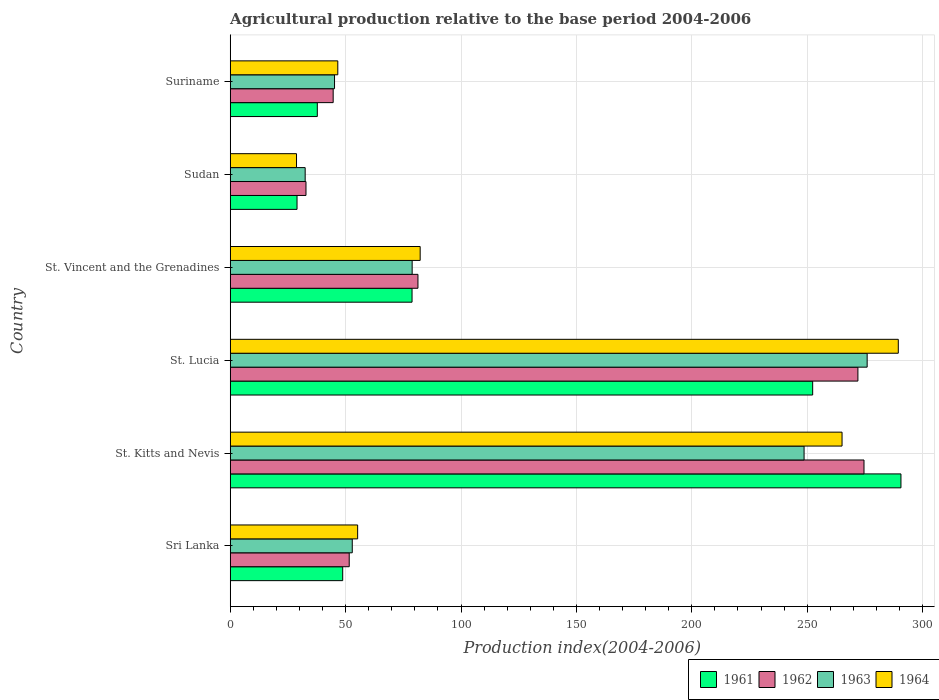Are the number of bars per tick equal to the number of legend labels?
Provide a short and direct response. Yes. Are the number of bars on each tick of the Y-axis equal?
Provide a short and direct response. Yes. How many bars are there on the 2nd tick from the bottom?
Your response must be concise. 4. What is the label of the 2nd group of bars from the top?
Your response must be concise. Sudan. In how many cases, is the number of bars for a given country not equal to the number of legend labels?
Provide a short and direct response. 0. What is the agricultural production index in 1961 in St. Lucia?
Your answer should be very brief. 252.36. Across all countries, what is the maximum agricultural production index in 1962?
Offer a terse response. 274.6. Across all countries, what is the minimum agricultural production index in 1961?
Your response must be concise. 28.96. In which country was the agricultural production index in 1961 maximum?
Make the answer very short. St. Kitts and Nevis. In which country was the agricultural production index in 1961 minimum?
Your response must be concise. Sudan. What is the total agricultural production index in 1963 in the graph?
Your response must be concise. 734.04. What is the difference between the agricultural production index in 1963 in St. Lucia and the agricultural production index in 1961 in Sri Lanka?
Give a very brief answer. 227.22. What is the average agricultural production index in 1961 per country?
Keep it short and to the point. 122.87. What is the difference between the agricultural production index in 1961 and agricultural production index in 1963 in Suriname?
Offer a very short reply. -7.46. What is the ratio of the agricultural production index in 1963 in St. Lucia to that in Sudan?
Provide a succinct answer. 8.49. Is the agricultural production index in 1964 in St. Vincent and the Grenadines less than that in Suriname?
Give a very brief answer. No. Is the difference between the agricultural production index in 1961 in St. Lucia and Suriname greater than the difference between the agricultural production index in 1963 in St. Lucia and Suriname?
Provide a short and direct response. No. What is the difference between the highest and the second highest agricultural production index in 1962?
Your response must be concise. 2.64. What is the difference between the highest and the lowest agricultural production index in 1963?
Offer a terse response. 243.48. In how many countries, is the agricultural production index in 1961 greater than the average agricultural production index in 1961 taken over all countries?
Your answer should be compact. 2. Is it the case that in every country, the sum of the agricultural production index in 1963 and agricultural production index in 1964 is greater than the sum of agricultural production index in 1961 and agricultural production index in 1962?
Make the answer very short. No. What does the 1st bar from the top in St. Vincent and the Grenadines represents?
Your answer should be very brief. 1964. What does the 2nd bar from the bottom in St. Vincent and the Grenadines represents?
Make the answer very short. 1962. How many bars are there?
Provide a short and direct response. 24. Are all the bars in the graph horizontal?
Give a very brief answer. Yes. What is the difference between two consecutive major ticks on the X-axis?
Keep it short and to the point. 50. Does the graph contain any zero values?
Offer a very short reply. No. Does the graph contain grids?
Your answer should be compact. Yes. How many legend labels are there?
Offer a very short reply. 4. What is the title of the graph?
Your answer should be compact. Agricultural production relative to the base period 2004-2006. Does "1982" appear as one of the legend labels in the graph?
Keep it short and to the point. No. What is the label or title of the X-axis?
Ensure brevity in your answer.  Production index(2004-2006). What is the Production index(2004-2006) of 1961 in Sri Lanka?
Your answer should be very brief. 48.75. What is the Production index(2004-2006) of 1962 in Sri Lanka?
Offer a very short reply. 51.57. What is the Production index(2004-2006) in 1963 in Sri Lanka?
Keep it short and to the point. 52.89. What is the Production index(2004-2006) in 1964 in Sri Lanka?
Offer a terse response. 55.22. What is the Production index(2004-2006) of 1961 in St. Kitts and Nevis?
Offer a very short reply. 290.61. What is the Production index(2004-2006) of 1962 in St. Kitts and Nevis?
Keep it short and to the point. 274.6. What is the Production index(2004-2006) of 1963 in St. Kitts and Nevis?
Offer a very short reply. 248.64. What is the Production index(2004-2006) of 1964 in St. Kitts and Nevis?
Your answer should be very brief. 265.09. What is the Production index(2004-2006) in 1961 in St. Lucia?
Offer a very short reply. 252.36. What is the Production index(2004-2006) of 1962 in St. Lucia?
Keep it short and to the point. 271.96. What is the Production index(2004-2006) in 1963 in St. Lucia?
Your response must be concise. 275.97. What is the Production index(2004-2006) of 1964 in St. Lucia?
Provide a short and direct response. 289.46. What is the Production index(2004-2006) in 1961 in St. Vincent and the Grenadines?
Your answer should be very brief. 78.79. What is the Production index(2004-2006) in 1962 in St. Vincent and the Grenadines?
Provide a succinct answer. 81.35. What is the Production index(2004-2006) in 1963 in St. Vincent and the Grenadines?
Offer a very short reply. 78.84. What is the Production index(2004-2006) of 1964 in St. Vincent and the Grenadines?
Provide a succinct answer. 82.31. What is the Production index(2004-2006) in 1961 in Sudan?
Offer a terse response. 28.96. What is the Production index(2004-2006) of 1962 in Sudan?
Your answer should be compact. 32.84. What is the Production index(2004-2006) of 1963 in Sudan?
Your answer should be compact. 32.49. What is the Production index(2004-2006) in 1964 in Sudan?
Make the answer very short. 28.74. What is the Production index(2004-2006) in 1961 in Suriname?
Provide a succinct answer. 37.75. What is the Production index(2004-2006) of 1962 in Suriname?
Offer a terse response. 44.62. What is the Production index(2004-2006) of 1963 in Suriname?
Your response must be concise. 45.21. What is the Production index(2004-2006) in 1964 in Suriname?
Your answer should be compact. 46.62. Across all countries, what is the maximum Production index(2004-2006) of 1961?
Your answer should be compact. 290.61. Across all countries, what is the maximum Production index(2004-2006) of 1962?
Your answer should be compact. 274.6. Across all countries, what is the maximum Production index(2004-2006) in 1963?
Your answer should be compact. 275.97. Across all countries, what is the maximum Production index(2004-2006) in 1964?
Make the answer very short. 289.46. Across all countries, what is the minimum Production index(2004-2006) of 1961?
Give a very brief answer. 28.96. Across all countries, what is the minimum Production index(2004-2006) in 1962?
Make the answer very short. 32.84. Across all countries, what is the minimum Production index(2004-2006) in 1963?
Keep it short and to the point. 32.49. Across all countries, what is the minimum Production index(2004-2006) of 1964?
Offer a very short reply. 28.74. What is the total Production index(2004-2006) of 1961 in the graph?
Provide a succinct answer. 737.22. What is the total Production index(2004-2006) in 1962 in the graph?
Offer a very short reply. 756.94. What is the total Production index(2004-2006) of 1963 in the graph?
Your answer should be compact. 734.04. What is the total Production index(2004-2006) in 1964 in the graph?
Give a very brief answer. 767.44. What is the difference between the Production index(2004-2006) of 1961 in Sri Lanka and that in St. Kitts and Nevis?
Provide a short and direct response. -241.86. What is the difference between the Production index(2004-2006) in 1962 in Sri Lanka and that in St. Kitts and Nevis?
Keep it short and to the point. -223.03. What is the difference between the Production index(2004-2006) in 1963 in Sri Lanka and that in St. Kitts and Nevis?
Keep it short and to the point. -195.75. What is the difference between the Production index(2004-2006) in 1964 in Sri Lanka and that in St. Kitts and Nevis?
Give a very brief answer. -209.87. What is the difference between the Production index(2004-2006) of 1961 in Sri Lanka and that in St. Lucia?
Offer a very short reply. -203.61. What is the difference between the Production index(2004-2006) in 1962 in Sri Lanka and that in St. Lucia?
Your answer should be compact. -220.39. What is the difference between the Production index(2004-2006) of 1963 in Sri Lanka and that in St. Lucia?
Offer a terse response. -223.08. What is the difference between the Production index(2004-2006) in 1964 in Sri Lanka and that in St. Lucia?
Provide a succinct answer. -234.24. What is the difference between the Production index(2004-2006) of 1961 in Sri Lanka and that in St. Vincent and the Grenadines?
Keep it short and to the point. -30.04. What is the difference between the Production index(2004-2006) of 1962 in Sri Lanka and that in St. Vincent and the Grenadines?
Keep it short and to the point. -29.78. What is the difference between the Production index(2004-2006) in 1963 in Sri Lanka and that in St. Vincent and the Grenadines?
Your answer should be very brief. -25.95. What is the difference between the Production index(2004-2006) in 1964 in Sri Lanka and that in St. Vincent and the Grenadines?
Offer a terse response. -27.09. What is the difference between the Production index(2004-2006) in 1961 in Sri Lanka and that in Sudan?
Keep it short and to the point. 19.79. What is the difference between the Production index(2004-2006) in 1962 in Sri Lanka and that in Sudan?
Your answer should be compact. 18.73. What is the difference between the Production index(2004-2006) of 1963 in Sri Lanka and that in Sudan?
Keep it short and to the point. 20.4. What is the difference between the Production index(2004-2006) in 1964 in Sri Lanka and that in Sudan?
Your answer should be compact. 26.48. What is the difference between the Production index(2004-2006) of 1962 in Sri Lanka and that in Suriname?
Your answer should be compact. 6.95. What is the difference between the Production index(2004-2006) of 1963 in Sri Lanka and that in Suriname?
Make the answer very short. 7.68. What is the difference between the Production index(2004-2006) in 1961 in St. Kitts and Nevis and that in St. Lucia?
Your answer should be compact. 38.25. What is the difference between the Production index(2004-2006) of 1962 in St. Kitts and Nevis and that in St. Lucia?
Give a very brief answer. 2.64. What is the difference between the Production index(2004-2006) in 1963 in St. Kitts and Nevis and that in St. Lucia?
Offer a terse response. -27.33. What is the difference between the Production index(2004-2006) of 1964 in St. Kitts and Nevis and that in St. Lucia?
Provide a short and direct response. -24.37. What is the difference between the Production index(2004-2006) of 1961 in St. Kitts and Nevis and that in St. Vincent and the Grenadines?
Give a very brief answer. 211.82. What is the difference between the Production index(2004-2006) in 1962 in St. Kitts and Nevis and that in St. Vincent and the Grenadines?
Make the answer very short. 193.25. What is the difference between the Production index(2004-2006) in 1963 in St. Kitts and Nevis and that in St. Vincent and the Grenadines?
Provide a succinct answer. 169.8. What is the difference between the Production index(2004-2006) of 1964 in St. Kitts and Nevis and that in St. Vincent and the Grenadines?
Keep it short and to the point. 182.78. What is the difference between the Production index(2004-2006) in 1961 in St. Kitts and Nevis and that in Sudan?
Keep it short and to the point. 261.65. What is the difference between the Production index(2004-2006) in 1962 in St. Kitts and Nevis and that in Sudan?
Your answer should be very brief. 241.76. What is the difference between the Production index(2004-2006) in 1963 in St. Kitts and Nevis and that in Sudan?
Offer a very short reply. 216.15. What is the difference between the Production index(2004-2006) of 1964 in St. Kitts and Nevis and that in Sudan?
Offer a terse response. 236.35. What is the difference between the Production index(2004-2006) in 1961 in St. Kitts and Nevis and that in Suriname?
Keep it short and to the point. 252.86. What is the difference between the Production index(2004-2006) in 1962 in St. Kitts and Nevis and that in Suriname?
Offer a very short reply. 229.98. What is the difference between the Production index(2004-2006) in 1963 in St. Kitts and Nevis and that in Suriname?
Ensure brevity in your answer.  203.43. What is the difference between the Production index(2004-2006) in 1964 in St. Kitts and Nevis and that in Suriname?
Offer a very short reply. 218.47. What is the difference between the Production index(2004-2006) in 1961 in St. Lucia and that in St. Vincent and the Grenadines?
Ensure brevity in your answer.  173.57. What is the difference between the Production index(2004-2006) of 1962 in St. Lucia and that in St. Vincent and the Grenadines?
Offer a very short reply. 190.61. What is the difference between the Production index(2004-2006) of 1963 in St. Lucia and that in St. Vincent and the Grenadines?
Make the answer very short. 197.13. What is the difference between the Production index(2004-2006) in 1964 in St. Lucia and that in St. Vincent and the Grenadines?
Keep it short and to the point. 207.15. What is the difference between the Production index(2004-2006) of 1961 in St. Lucia and that in Sudan?
Keep it short and to the point. 223.4. What is the difference between the Production index(2004-2006) in 1962 in St. Lucia and that in Sudan?
Ensure brevity in your answer.  239.12. What is the difference between the Production index(2004-2006) in 1963 in St. Lucia and that in Sudan?
Your answer should be compact. 243.48. What is the difference between the Production index(2004-2006) of 1964 in St. Lucia and that in Sudan?
Ensure brevity in your answer.  260.72. What is the difference between the Production index(2004-2006) of 1961 in St. Lucia and that in Suriname?
Keep it short and to the point. 214.61. What is the difference between the Production index(2004-2006) in 1962 in St. Lucia and that in Suriname?
Your answer should be very brief. 227.34. What is the difference between the Production index(2004-2006) of 1963 in St. Lucia and that in Suriname?
Your response must be concise. 230.76. What is the difference between the Production index(2004-2006) of 1964 in St. Lucia and that in Suriname?
Your response must be concise. 242.84. What is the difference between the Production index(2004-2006) in 1961 in St. Vincent and the Grenadines and that in Sudan?
Offer a terse response. 49.83. What is the difference between the Production index(2004-2006) in 1962 in St. Vincent and the Grenadines and that in Sudan?
Make the answer very short. 48.51. What is the difference between the Production index(2004-2006) of 1963 in St. Vincent and the Grenadines and that in Sudan?
Ensure brevity in your answer.  46.35. What is the difference between the Production index(2004-2006) in 1964 in St. Vincent and the Grenadines and that in Sudan?
Make the answer very short. 53.57. What is the difference between the Production index(2004-2006) of 1961 in St. Vincent and the Grenadines and that in Suriname?
Ensure brevity in your answer.  41.04. What is the difference between the Production index(2004-2006) in 1962 in St. Vincent and the Grenadines and that in Suriname?
Provide a short and direct response. 36.73. What is the difference between the Production index(2004-2006) of 1963 in St. Vincent and the Grenadines and that in Suriname?
Offer a very short reply. 33.63. What is the difference between the Production index(2004-2006) in 1964 in St. Vincent and the Grenadines and that in Suriname?
Your answer should be very brief. 35.69. What is the difference between the Production index(2004-2006) in 1961 in Sudan and that in Suriname?
Provide a short and direct response. -8.79. What is the difference between the Production index(2004-2006) of 1962 in Sudan and that in Suriname?
Your answer should be very brief. -11.78. What is the difference between the Production index(2004-2006) of 1963 in Sudan and that in Suriname?
Provide a succinct answer. -12.72. What is the difference between the Production index(2004-2006) of 1964 in Sudan and that in Suriname?
Your response must be concise. -17.88. What is the difference between the Production index(2004-2006) of 1961 in Sri Lanka and the Production index(2004-2006) of 1962 in St. Kitts and Nevis?
Provide a succinct answer. -225.85. What is the difference between the Production index(2004-2006) of 1961 in Sri Lanka and the Production index(2004-2006) of 1963 in St. Kitts and Nevis?
Provide a short and direct response. -199.89. What is the difference between the Production index(2004-2006) of 1961 in Sri Lanka and the Production index(2004-2006) of 1964 in St. Kitts and Nevis?
Provide a succinct answer. -216.34. What is the difference between the Production index(2004-2006) in 1962 in Sri Lanka and the Production index(2004-2006) in 1963 in St. Kitts and Nevis?
Your response must be concise. -197.07. What is the difference between the Production index(2004-2006) in 1962 in Sri Lanka and the Production index(2004-2006) in 1964 in St. Kitts and Nevis?
Provide a succinct answer. -213.52. What is the difference between the Production index(2004-2006) in 1963 in Sri Lanka and the Production index(2004-2006) in 1964 in St. Kitts and Nevis?
Offer a terse response. -212.2. What is the difference between the Production index(2004-2006) of 1961 in Sri Lanka and the Production index(2004-2006) of 1962 in St. Lucia?
Offer a very short reply. -223.21. What is the difference between the Production index(2004-2006) of 1961 in Sri Lanka and the Production index(2004-2006) of 1963 in St. Lucia?
Ensure brevity in your answer.  -227.22. What is the difference between the Production index(2004-2006) of 1961 in Sri Lanka and the Production index(2004-2006) of 1964 in St. Lucia?
Offer a terse response. -240.71. What is the difference between the Production index(2004-2006) of 1962 in Sri Lanka and the Production index(2004-2006) of 1963 in St. Lucia?
Make the answer very short. -224.4. What is the difference between the Production index(2004-2006) in 1962 in Sri Lanka and the Production index(2004-2006) in 1964 in St. Lucia?
Your response must be concise. -237.89. What is the difference between the Production index(2004-2006) of 1963 in Sri Lanka and the Production index(2004-2006) of 1964 in St. Lucia?
Provide a succinct answer. -236.57. What is the difference between the Production index(2004-2006) in 1961 in Sri Lanka and the Production index(2004-2006) in 1962 in St. Vincent and the Grenadines?
Provide a short and direct response. -32.6. What is the difference between the Production index(2004-2006) of 1961 in Sri Lanka and the Production index(2004-2006) of 1963 in St. Vincent and the Grenadines?
Your response must be concise. -30.09. What is the difference between the Production index(2004-2006) of 1961 in Sri Lanka and the Production index(2004-2006) of 1964 in St. Vincent and the Grenadines?
Keep it short and to the point. -33.56. What is the difference between the Production index(2004-2006) in 1962 in Sri Lanka and the Production index(2004-2006) in 1963 in St. Vincent and the Grenadines?
Provide a succinct answer. -27.27. What is the difference between the Production index(2004-2006) of 1962 in Sri Lanka and the Production index(2004-2006) of 1964 in St. Vincent and the Grenadines?
Provide a short and direct response. -30.74. What is the difference between the Production index(2004-2006) of 1963 in Sri Lanka and the Production index(2004-2006) of 1964 in St. Vincent and the Grenadines?
Your answer should be very brief. -29.42. What is the difference between the Production index(2004-2006) of 1961 in Sri Lanka and the Production index(2004-2006) of 1962 in Sudan?
Provide a short and direct response. 15.91. What is the difference between the Production index(2004-2006) of 1961 in Sri Lanka and the Production index(2004-2006) of 1963 in Sudan?
Give a very brief answer. 16.26. What is the difference between the Production index(2004-2006) of 1961 in Sri Lanka and the Production index(2004-2006) of 1964 in Sudan?
Offer a terse response. 20.01. What is the difference between the Production index(2004-2006) of 1962 in Sri Lanka and the Production index(2004-2006) of 1963 in Sudan?
Your answer should be compact. 19.08. What is the difference between the Production index(2004-2006) in 1962 in Sri Lanka and the Production index(2004-2006) in 1964 in Sudan?
Your answer should be compact. 22.83. What is the difference between the Production index(2004-2006) in 1963 in Sri Lanka and the Production index(2004-2006) in 1964 in Sudan?
Your response must be concise. 24.15. What is the difference between the Production index(2004-2006) of 1961 in Sri Lanka and the Production index(2004-2006) of 1962 in Suriname?
Offer a very short reply. 4.13. What is the difference between the Production index(2004-2006) of 1961 in Sri Lanka and the Production index(2004-2006) of 1963 in Suriname?
Give a very brief answer. 3.54. What is the difference between the Production index(2004-2006) of 1961 in Sri Lanka and the Production index(2004-2006) of 1964 in Suriname?
Provide a short and direct response. 2.13. What is the difference between the Production index(2004-2006) of 1962 in Sri Lanka and the Production index(2004-2006) of 1963 in Suriname?
Your answer should be compact. 6.36. What is the difference between the Production index(2004-2006) of 1962 in Sri Lanka and the Production index(2004-2006) of 1964 in Suriname?
Your answer should be compact. 4.95. What is the difference between the Production index(2004-2006) in 1963 in Sri Lanka and the Production index(2004-2006) in 1964 in Suriname?
Provide a succinct answer. 6.27. What is the difference between the Production index(2004-2006) of 1961 in St. Kitts and Nevis and the Production index(2004-2006) of 1962 in St. Lucia?
Ensure brevity in your answer.  18.65. What is the difference between the Production index(2004-2006) in 1961 in St. Kitts and Nevis and the Production index(2004-2006) in 1963 in St. Lucia?
Provide a succinct answer. 14.64. What is the difference between the Production index(2004-2006) in 1961 in St. Kitts and Nevis and the Production index(2004-2006) in 1964 in St. Lucia?
Offer a terse response. 1.15. What is the difference between the Production index(2004-2006) in 1962 in St. Kitts and Nevis and the Production index(2004-2006) in 1963 in St. Lucia?
Offer a terse response. -1.37. What is the difference between the Production index(2004-2006) of 1962 in St. Kitts and Nevis and the Production index(2004-2006) of 1964 in St. Lucia?
Keep it short and to the point. -14.86. What is the difference between the Production index(2004-2006) of 1963 in St. Kitts and Nevis and the Production index(2004-2006) of 1964 in St. Lucia?
Your answer should be very brief. -40.82. What is the difference between the Production index(2004-2006) in 1961 in St. Kitts and Nevis and the Production index(2004-2006) in 1962 in St. Vincent and the Grenadines?
Keep it short and to the point. 209.26. What is the difference between the Production index(2004-2006) of 1961 in St. Kitts and Nevis and the Production index(2004-2006) of 1963 in St. Vincent and the Grenadines?
Offer a terse response. 211.77. What is the difference between the Production index(2004-2006) of 1961 in St. Kitts and Nevis and the Production index(2004-2006) of 1964 in St. Vincent and the Grenadines?
Offer a terse response. 208.3. What is the difference between the Production index(2004-2006) of 1962 in St. Kitts and Nevis and the Production index(2004-2006) of 1963 in St. Vincent and the Grenadines?
Your response must be concise. 195.76. What is the difference between the Production index(2004-2006) in 1962 in St. Kitts and Nevis and the Production index(2004-2006) in 1964 in St. Vincent and the Grenadines?
Offer a terse response. 192.29. What is the difference between the Production index(2004-2006) in 1963 in St. Kitts and Nevis and the Production index(2004-2006) in 1964 in St. Vincent and the Grenadines?
Make the answer very short. 166.33. What is the difference between the Production index(2004-2006) of 1961 in St. Kitts and Nevis and the Production index(2004-2006) of 1962 in Sudan?
Your answer should be very brief. 257.77. What is the difference between the Production index(2004-2006) of 1961 in St. Kitts and Nevis and the Production index(2004-2006) of 1963 in Sudan?
Your answer should be very brief. 258.12. What is the difference between the Production index(2004-2006) in 1961 in St. Kitts and Nevis and the Production index(2004-2006) in 1964 in Sudan?
Provide a succinct answer. 261.87. What is the difference between the Production index(2004-2006) in 1962 in St. Kitts and Nevis and the Production index(2004-2006) in 1963 in Sudan?
Make the answer very short. 242.11. What is the difference between the Production index(2004-2006) in 1962 in St. Kitts and Nevis and the Production index(2004-2006) in 1964 in Sudan?
Your answer should be compact. 245.86. What is the difference between the Production index(2004-2006) in 1963 in St. Kitts and Nevis and the Production index(2004-2006) in 1964 in Sudan?
Ensure brevity in your answer.  219.9. What is the difference between the Production index(2004-2006) in 1961 in St. Kitts and Nevis and the Production index(2004-2006) in 1962 in Suriname?
Provide a short and direct response. 245.99. What is the difference between the Production index(2004-2006) of 1961 in St. Kitts and Nevis and the Production index(2004-2006) of 1963 in Suriname?
Your answer should be compact. 245.4. What is the difference between the Production index(2004-2006) of 1961 in St. Kitts and Nevis and the Production index(2004-2006) of 1964 in Suriname?
Offer a terse response. 243.99. What is the difference between the Production index(2004-2006) of 1962 in St. Kitts and Nevis and the Production index(2004-2006) of 1963 in Suriname?
Provide a succinct answer. 229.39. What is the difference between the Production index(2004-2006) of 1962 in St. Kitts and Nevis and the Production index(2004-2006) of 1964 in Suriname?
Give a very brief answer. 227.98. What is the difference between the Production index(2004-2006) of 1963 in St. Kitts and Nevis and the Production index(2004-2006) of 1964 in Suriname?
Give a very brief answer. 202.02. What is the difference between the Production index(2004-2006) of 1961 in St. Lucia and the Production index(2004-2006) of 1962 in St. Vincent and the Grenadines?
Offer a very short reply. 171.01. What is the difference between the Production index(2004-2006) of 1961 in St. Lucia and the Production index(2004-2006) of 1963 in St. Vincent and the Grenadines?
Make the answer very short. 173.52. What is the difference between the Production index(2004-2006) of 1961 in St. Lucia and the Production index(2004-2006) of 1964 in St. Vincent and the Grenadines?
Ensure brevity in your answer.  170.05. What is the difference between the Production index(2004-2006) of 1962 in St. Lucia and the Production index(2004-2006) of 1963 in St. Vincent and the Grenadines?
Your response must be concise. 193.12. What is the difference between the Production index(2004-2006) of 1962 in St. Lucia and the Production index(2004-2006) of 1964 in St. Vincent and the Grenadines?
Your response must be concise. 189.65. What is the difference between the Production index(2004-2006) of 1963 in St. Lucia and the Production index(2004-2006) of 1964 in St. Vincent and the Grenadines?
Keep it short and to the point. 193.66. What is the difference between the Production index(2004-2006) in 1961 in St. Lucia and the Production index(2004-2006) in 1962 in Sudan?
Keep it short and to the point. 219.52. What is the difference between the Production index(2004-2006) of 1961 in St. Lucia and the Production index(2004-2006) of 1963 in Sudan?
Provide a succinct answer. 219.87. What is the difference between the Production index(2004-2006) of 1961 in St. Lucia and the Production index(2004-2006) of 1964 in Sudan?
Provide a succinct answer. 223.62. What is the difference between the Production index(2004-2006) of 1962 in St. Lucia and the Production index(2004-2006) of 1963 in Sudan?
Your answer should be very brief. 239.47. What is the difference between the Production index(2004-2006) in 1962 in St. Lucia and the Production index(2004-2006) in 1964 in Sudan?
Give a very brief answer. 243.22. What is the difference between the Production index(2004-2006) of 1963 in St. Lucia and the Production index(2004-2006) of 1964 in Sudan?
Make the answer very short. 247.23. What is the difference between the Production index(2004-2006) of 1961 in St. Lucia and the Production index(2004-2006) of 1962 in Suriname?
Provide a short and direct response. 207.74. What is the difference between the Production index(2004-2006) in 1961 in St. Lucia and the Production index(2004-2006) in 1963 in Suriname?
Provide a succinct answer. 207.15. What is the difference between the Production index(2004-2006) of 1961 in St. Lucia and the Production index(2004-2006) of 1964 in Suriname?
Provide a succinct answer. 205.74. What is the difference between the Production index(2004-2006) in 1962 in St. Lucia and the Production index(2004-2006) in 1963 in Suriname?
Make the answer very short. 226.75. What is the difference between the Production index(2004-2006) of 1962 in St. Lucia and the Production index(2004-2006) of 1964 in Suriname?
Provide a short and direct response. 225.34. What is the difference between the Production index(2004-2006) in 1963 in St. Lucia and the Production index(2004-2006) in 1964 in Suriname?
Provide a short and direct response. 229.35. What is the difference between the Production index(2004-2006) in 1961 in St. Vincent and the Grenadines and the Production index(2004-2006) in 1962 in Sudan?
Offer a very short reply. 45.95. What is the difference between the Production index(2004-2006) of 1961 in St. Vincent and the Grenadines and the Production index(2004-2006) of 1963 in Sudan?
Give a very brief answer. 46.3. What is the difference between the Production index(2004-2006) of 1961 in St. Vincent and the Grenadines and the Production index(2004-2006) of 1964 in Sudan?
Your response must be concise. 50.05. What is the difference between the Production index(2004-2006) of 1962 in St. Vincent and the Grenadines and the Production index(2004-2006) of 1963 in Sudan?
Provide a short and direct response. 48.86. What is the difference between the Production index(2004-2006) of 1962 in St. Vincent and the Grenadines and the Production index(2004-2006) of 1964 in Sudan?
Offer a very short reply. 52.61. What is the difference between the Production index(2004-2006) in 1963 in St. Vincent and the Grenadines and the Production index(2004-2006) in 1964 in Sudan?
Offer a terse response. 50.1. What is the difference between the Production index(2004-2006) of 1961 in St. Vincent and the Grenadines and the Production index(2004-2006) of 1962 in Suriname?
Your answer should be compact. 34.17. What is the difference between the Production index(2004-2006) in 1961 in St. Vincent and the Grenadines and the Production index(2004-2006) in 1963 in Suriname?
Your answer should be compact. 33.58. What is the difference between the Production index(2004-2006) in 1961 in St. Vincent and the Grenadines and the Production index(2004-2006) in 1964 in Suriname?
Your response must be concise. 32.17. What is the difference between the Production index(2004-2006) of 1962 in St. Vincent and the Grenadines and the Production index(2004-2006) of 1963 in Suriname?
Make the answer very short. 36.14. What is the difference between the Production index(2004-2006) in 1962 in St. Vincent and the Grenadines and the Production index(2004-2006) in 1964 in Suriname?
Your answer should be compact. 34.73. What is the difference between the Production index(2004-2006) in 1963 in St. Vincent and the Grenadines and the Production index(2004-2006) in 1964 in Suriname?
Your answer should be compact. 32.22. What is the difference between the Production index(2004-2006) of 1961 in Sudan and the Production index(2004-2006) of 1962 in Suriname?
Provide a succinct answer. -15.66. What is the difference between the Production index(2004-2006) in 1961 in Sudan and the Production index(2004-2006) in 1963 in Suriname?
Offer a terse response. -16.25. What is the difference between the Production index(2004-2006) in 1961 in Sudan and the Production index(2004-2006) in 1964 in Suriname?
Give a very brief answer. -17.66. What is the difference between the Production index(2004-2006) of 1962 in Sudan and the Production index(2004-2006) of 1963 in Suriname?
Offer a very short reply. -12.37. What is the difference between the Production index(2004-2006) of 1962 in Sudan and the Production index(2004-2006) of 1964 in Suriname?
Your answer should be very brief. -13.78. What is the difference between the Production index(2004-2006) of 1963 in Sudan and the Production index(2004-2006) of 1964 in Suriname?
Ensure brevity in your answer.  -14.13. What is the average Production index(2004-2006) of 1961 per country?
Make the answer very short. 122.87. What is the average Production index(2004-2006) in 1962 per country?
Offer a terse response. 126.16. What is the average Production index(2004-2006) of 1963 per country?
Your response must be concise. 122.34. What is the average Production index(2004-2006) of 1964 per country?
Make the answer very short. 127.91. What is the difference between the Production index(2004-2006) in 1961 and Production index(2004-2006) in 1962 in Sri Lanka?
Provide a succinct answer. -2.82. What is the difference between the Production index(2004-2006) of 1961 and Production index(2004-2006) of 1963 in Sri Lanka?
Your answer should be very brief. -4.14. What is the difference between the Production index(2004-2006) of 1961 and Production index(2004-2006) of 1964 in Sri Lanka?
Provide a short and direct response. -6.47. What is the difference between the Production index(2004-2006) of 1962 and Production index(2004-2006) of 1963 in Sri Lanka?
Offer a very short reply. -1.32. What is the difference between the Production index(2004-2006) in 1962 and Production index(2004-2006) in 1964 in Sri Lanka?
Your answer should be very brief. -3.65. What is the difference between the Production index(2004-2006) of 1963 and Production index(2004-2006) of 1964 in Sri Lanka?
Give a very brief answer. -2.33. What is the difference between the Production index(2004-2006) of 1961 and Production index(2004-2006) of 1962 in St. Kitts and Nevis?
Give a very brief answer. 16.01. What is the difference between the Production index(2004-2006) of 1961 and Production index(2004-2006) of 1963 in St. Kitts and Nevis?
Make the answer very short. 41.97. What is the difference between the Production index(2004-2006) of 1961 and Production index(2004-2006) of 1964 in St. Kitts and Nevis?
Your answer should be compact. 25.52. What is the difference between the Production index(2004-2006) in 1962 and Production index(2004-2006) in 1963 in St. Kitts and Nevis?
Your answer should be very brief. 25.96. What is the difference between the Production index(2004-2006) of 1962 and Production index(2004-2006) of 1964 in St. Kitts and Nevis?
Your answer should be very brief. 9.51. What is the difference between the Production index(2004-2006) in 1963 and Production index(2004-2006) in 1964 in St. Kitts and Nevis?
Offer a very short reply. -16.45. What is the difference between the Production index(2004-2006) of 1961 and Production index(2004-2006) of 1962 in St. Lucia?
Your response must be concise. -19.6. What is the difference between the Production index(2004-2006) of 1961 and Production index(2004-2006) of 1963 in St. Lucia?
Your answer should be compact. -23.61. What is the difference between the Production index(2004-2006) of 1961 and Production index(2004-2006) of 1964 in St. Lucia?
Give a very brief answer. -37.1. What is the difference between the Production index(2004-2006) of 1962 and Production index(2004-2006) of 1963 in St. Lucia?
Your answer should be compact. -4.01. What is the difference between the Production index(2004-2006) of 1962 and Production index(2004-2006) of 1964 in St. Lucia?
Provide a short and direct response. -17.5. What is the difference between the Production index(2004-2006) of 1963 and Production index(2004-2006) of 1964 in St. Lucia?
Offer a very short reply. -13.49. What is the difference between the Production index(2004-2006) in 1961 and Production index(2004-2006) in 1962 in St. Vincent and the Grenadines?
Give a very brief answer. -2.56. What is the difference between the Production index(2004-2006) of 1961 and Production index(2004-2006) of 1963 in St. Vincent and the Grenadines?
Offer a very short reply. -0.05. What is the difference between the Production index(2004-2006) of 1961 and Production index(2004-2006) of 1964 in St. Vincent and the Grenadines?
Provide a succinct answer. -3.52. What is the difference between the Production index(2004-2006) of 1962 and Production index(2004-2006) of 1963 in St. Vincent and the Grenadines?
Keep it short and to the point. 2.51. What is the difference between the Production index(2004-2006) of 1962 and Production index(2004-2006) of 1964 in St. Vincent and the Grenadines?
Make the answer very short. -0.96. What is the difference between the Production index(2004-2006) of 1963 and Production index(2004-2006) of 1964 in St. Vincent and the Grenadines?
Provide a short and direct response. -3.47. What is the difference between the Production index(2004-2006) in 1961 and Production index(2004-2006) in 1962 in Sudan?
Your response must be concise. -3.88. What is the difference between the Production index(2004-2006) in 1961 and Production index(2004-2006) in 1963 in Sudan?
Your response must be concise. -3.53. What is the difference between the Production index(2004-2006) of 1961 and Production index(2004-2006) of 1964 in Sudan?
Keep it short and to the point. 0.22. What is the difference between the Production index(2004-2006) of 1962 and Production index(2004-2006) of 1963 in Sudan?
Make the answer very short. 0.35. What is the difference between the Production index(2004-2006) of 1962 and Production index(2004-2006) of 1964 in Sudan?
Ensure brevity in your answer.  4.1. What is the difference between the Production index(2004-2006) in 1963 and Production index(2004-2006) in 1964 in Sudan?
Ensure brevity in your answer.  3.75. What is the difference between the Production index(2004-2006) in 1961 and Production index(2004-2006) in 1962 in Suriname?
Offer a very short reply. -6.87. What is the difference between the Production index(2004-2006) in 1961 and Production index(2004-2006) in 1963 in Suriname?
Provide a succinct answer. -7.46. What is the difference between the Production index(2004-2006) in 1961 and Production index(2004-2006) in 1964 in Suriname?
Provide a short and direct response. -8.87. What is the difference between the Production index(2004-2006) of 1962 and Production index(2004-2006) of 1963 in Suriname?
Ensure brevity in your answer.  -0.59. What is the difference between the Production index(2004-2006) of 1963 and Production index(2004-2006) of 1964 in Suriname?
Offer a terse response. -1.41. What is the ratio of the Production index(2004-2006) of 1961 in Sri Lanka to that in St. Kitts and Nevis?
Your response must be concise. 0.17. What is the ratio of the Production index(2004-2006) of 1962 in Sri Lanka to that in St. Kitts and Nevis?
Provide a succinct answer. 0.19. What is the ratio of the Production index(2004-2006) in 1963 in Sri Lanka to that in St. Kitts and Nevis?
Your answer should be compact. 0.21. What is the ratio of the Production index(2004-2006) in 1964 in Sri Lanka to that in St. Kitts and Nevis?
Provide a short and direct response. 0.21. What is the ratio of the Production index(2004-2006) of 1961 in Sri Lanka to that in St. Lucia?
Provide a short and direct response. 0.19. What is the ratio of the Production index(2004-2006) in 1962 in Sri Lanka to that in St. Lucia?
Make the answer very short. 0.19. What is the ratio of the Production index(2004-2006) in 1963 in Sri Lanka to that in St. Lucia?
Make the answer very short. 0.19. What is the ratio of the Production index(2004-2006) in 1964 in Sri Lanka to that in St. Lucia?
Make the answer very short. 0.19. What is the ratio of the Production index(2004-2006) of 1961 in Sri Lanka to that in St. Vincent and the Grenadines?
Your response must be concise. 0.62. What is the ratio of the Production index(2004-2006) of 1962 in Sri Lanka to that in St. Vincent and the Grenadines?
Give a very brief answer. 0.63. What is the ratio of the Production index(2004-2006) of 1963 in Sri Lanka to that in St. Vincent and the Grenadines?
Provide a succinct answer. 0.67. What is the ratio of the Production index(2004-2006) in 1964 in Sri Lanka to that in St. Vincent and the Grenadines?
Your answer should be very brief. 0.67. What is the ratio of the Production index(2004-2006) in 1961 in Sri Lanka to that in Sudan?
Your answer should be compact. 1.68. What is the ratio of the Production index(2004-2006) of 1962 in Sri Lanka to that in Sudan?
Make the answer very short. 1.57. What is the ratio of the Production index(2004-2006) of 1963 in Sri Lanka to that in Sudan?
Ensure brevity in your answer.  1.63. What is the ratio of the Production index(2004-2006) in 1964 in Sri Lanka to that in Sudan?
Ensure brevity in your answer.  1.92. What is the ratio of the Production index(2004-2006) in 1961 in Sri Lanka to that in Suriname?
Make the answer very short. 1.29. What is the ratio of the Production index(2004-2006) in 1962 in Sri Lanka to that in Suriname?
Your answer should be compact. 1.16. What is the ratio of the Production index(2004-2006) of 1963 in Sri Lanka to that in Suriname?
Keep it short and to the point. 1.17. What is the ratio of the Production index(2004-2006) in 1964 in Sri Lanka to that in Suriname?
Ensure brevity in your answer.  1.18. What is the ratio of the Production index(2004-2006) of 1961 in St. Kitts and Nevis to that in St. Lucia?
Ensure brevity in your answer.  1.15. What is the ratio of the Production index(2004-2006) of 1962 in St. Kitts and Nevis to that in St. Lucia?
Your answer should be very brief. 1.01. What is the ratio of the Production index(2004-2006) of 1963 in St. Kitts and Nevis to that in St. Lucia?
Ensure brevity in your answer.  0.9. What is the ratio of the Production index(2004-2006) in 1964 in St. Kitts and Nevis to that in St. Lucia?
Your response must be concise. 0.92. What is the ratio of the Production index(2004-2006) of 1961 in St. Kitts and Nevis to that in St. Vincent and the Grenadines?
Keep it short and to the point. 3.69. What is the ratio of the Production index(2004-2006) of 1962 in St. Kitts and Nevis to that in St. Vincent and the Grenadines?
Ensure brevity in your answer.  3.38. What is the ratio of the Production index(2004-2006) in 1963 in St. Kitts and Nevis to that in St. Vincent and the Grenadines?
Offer a terse response. 3.15. What is the ratio of the Production index(2004-2006) of 1964 in St. Kitts and Nevis to that in St. Vincent and the Grenadines?
Offer a terse response. 3.22. What is the ratio of the Production index(2004-2006) of 1961 in St. Kitts and Nevis to that in Sudan?
Offer a terse response. 10.03. What is the ratio of the Production index(2004-2006) of 1962 in St. Kitts and Nevis to that in Sudan?
Offer a terse response. 8.36. What is the ratio of the Production index(2004-2006) of 1963 in St. Kitts and Nevis to that in Sudan?
Make the answer very short. 7.65. What is the ratio of the Production index(2004-2006) in 1964 in St. Kitts and Nevis to that in Sudan?
Ensure brevity in your answer.  9.22. What is the ratio of the Production index(2004-2006) in 1961 in St. Kitts and Nevis to that in Suriname?
Your response must be concise. 7.7. What is the ratio of the Production index(2004-2006) in 1962 in St. Kitts and Nevis to that in Suriname?
Offer a very short reply. 6.15. What is the ratio of the Production index(2004-2006) in 1963 in St. Kitts and Nevis to that in Suriname?
Offer a terse response. 5.5. What is the ratio of the Production index(2004-2006) in 1964 in St. Kitts and Nevis to that in Suriname?
Your answer should be compact. 5.69. What is the ratio of the Production index(2004-2006) of 1961 in St. Lucia to that in St. Vincent and the Grenadines?
Offer a terse response. 3.2. What is the ratio of the Production index(2004-2006) in 1962 in St. Lucia to that in St. Vincent and the Grenadines?
Your answer should be compact. 3.34. What is the ratio of the Production index(2004-2006) in 1963 in St. Lucia to that in St. Vincent and the Grenadines?
Keep it short and to the point. 3.5. What is the ratio of the Production index(2004-2006) in 1964 in St. Lucia to that in St. Vincent and the Grenadines?
Ensure brevity in your answer.  3.52. What is the ratio of the Production index(2004-2006) in 1961 in St. Lucia to that in Sudan?
Provide a short and direct response. 8.71. What is the ratio of the Production index(2004-2006) in 1962 in St. Lucia to that in Sudan?
Your answer should be very brief. 8.28. What is the ratio of the Production index(2004-2006) in 1963 in St. Lucia to that in Sudan?
Keep it short and to the point. 8.49. What is the ratio of the Production index(2004-2006) of 1964 in St. Lucia to that in Sudan?
Provide a succinct answer. 10.07. What is the ratio of the Production index(2004-2006) of 1961 in St. Lucia to that in Suriname?
Your answer should be very brief. 6.68. What is the ratio of the Production index(2004-2006) in 1962 in St. Lucia to that in Suriname?
Provide a succinct answer. 6.09. What is the ratio of the Production index(2004-2006) of 1963 in St. Lucia to that in Suriname?
Offer a very short reply. 6.1. What is the ratio of the Production index(2004-2006) of 1964 in St. Lucia to that in Suriname?
Your answer should be compact. 6.21. What is the ratio of the Production index(2004-2006) of 1961 in St. Vincent and the Grenadines to that in Sudan?
Your answer should be compact. 2.72. What is the ratio of the Production index(2004-2006) in 1962 in St. Vincent and the Grenadines to that in Sudan?
Offer a terse response. 2.48. What is the ratio of the Production index(2004-2006) of 1963 in St. Vincent and the Grenadines to that in Sudan?
Make the answer very short. 2.43. What is the ratio of the Production index(2004-2006) in 1964 in St. Vincent and the Grenadines to that in Sudan?
Offer a very short reply. 2.86. What is the ratio of the Production index(2004-2006) of 1961 in St. Vincent and the Grenadines to that in Suriname?
Provide a succinct answer. 2.09. What is the ratio of the Production index(2004-2006) of 1962 in St. Vincent and the Grenadines to that in Suriname?
Keep it short and to the point. 1.82. What is the ratio of the Production index(2004-2006) in 1963 in St. Vincent and the Grenadines to that in Suriname?
Give a very brief answer. 1.74. What is the ratio of the Production index(2004-2006) of 1964 in St. Vincent and the Grenadines to that in Suriname?
Ensure brevity in your answer.  1.77. What is the ratio of the Production index(2004-2006) of 1961 in Sudan to that in Suriname?
Ensure brevity in your answer.  0.77. What is the ratio of the Production index(2004-2006) in 1962 in Sudan to that in Suriname?
Offer a very short reply. 0.74. What is the ratio of the Production index(2004-2006) of 1963 in Sudan to that in Suriname?
Your answer should be very brief. 0.72. What is the ratio of the Production index(2004-2006) in 1964 in Sudan to that in Suriname?
Ensure brevity in your answer.  0.62. What is the difference between the highest and the second highest Production index(2004-2006) in 1961?
Your answer should be compact. 38.25. What is the difference between the highest and the second highest Production index(2004-2006) of 1962?
Make the answer very short. 2.64. What is the difference between the highest and the second highest Production index(2004-2006) in 1963?
Keep it short and to the point. 27.33. What is the difference between the highest and the second highest Production index(2004-2006) of 1964?
Offer a very short reply. 24.37. What is the difference between the highest and the lowest Production index(2004-2006) of 1961?
Offer a terse response. 261.65. What is the difference between the highest and the lowest Production index(2004-2006) in 1962?
Give a very brief answer. 241.76. What is the difference between the highest and the lowest Production index(2004-2006) of 1963?
Offer a terse response. 243.48. What is the difference between the highest and the lowest Production index(2004-2006) of 1964?
Offer a very short reply. 260.72. 